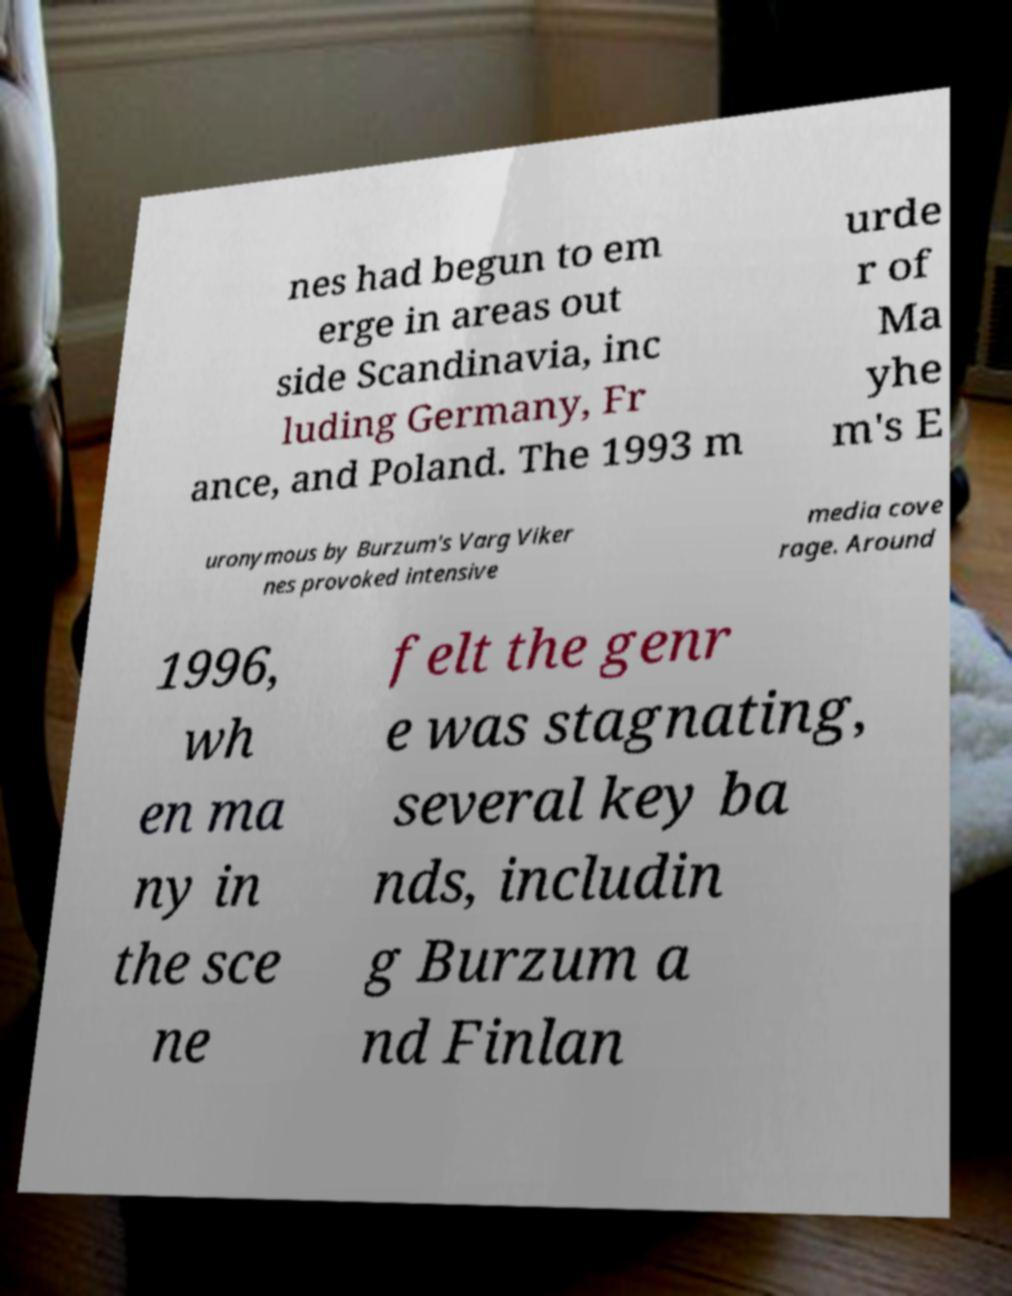For documentation purposes, I need the text within this image transcribed. Could you provide that? nes had begun to em erge in areas out side Scandinavia, inc luding Germany, Fr ance, and Poland. The 1993 m urde r of Ma yhe m's E uronymous by Burzum's Varg Viker nes provoked intensive media cove rage. Around 1996, wh en ma ny in the sce ne felt the genr e was stagnating, several key ba nds, includin g Burzum a nd Finlan 